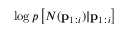Convert formula to latex. <formula><loc_0><loc_0><loc_500><loc_500>\log p \left [ N ( p _ { 1 \colon i } ) | p _ { 1 \colon i } \right ]</formula> 